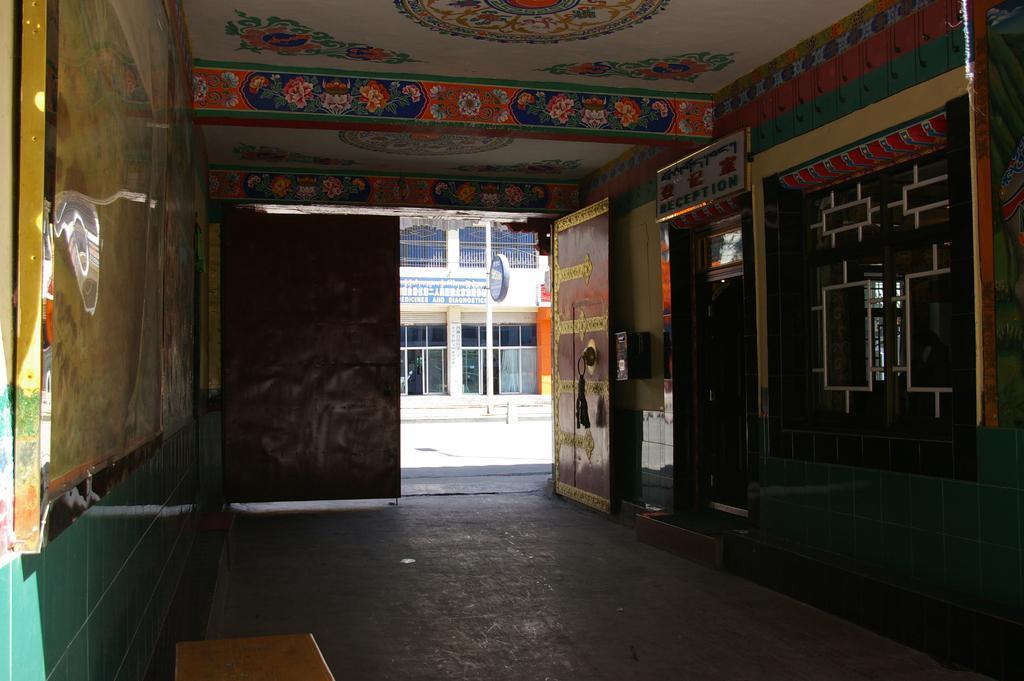Could you give a brief overview of what you see in this image? In this image in the center there is a door. On the right side there is a window and there is a board with some text written on it on it. On the left side there is a frame on the wall. Behind the door there is a building and there is a board with some text written on it. 